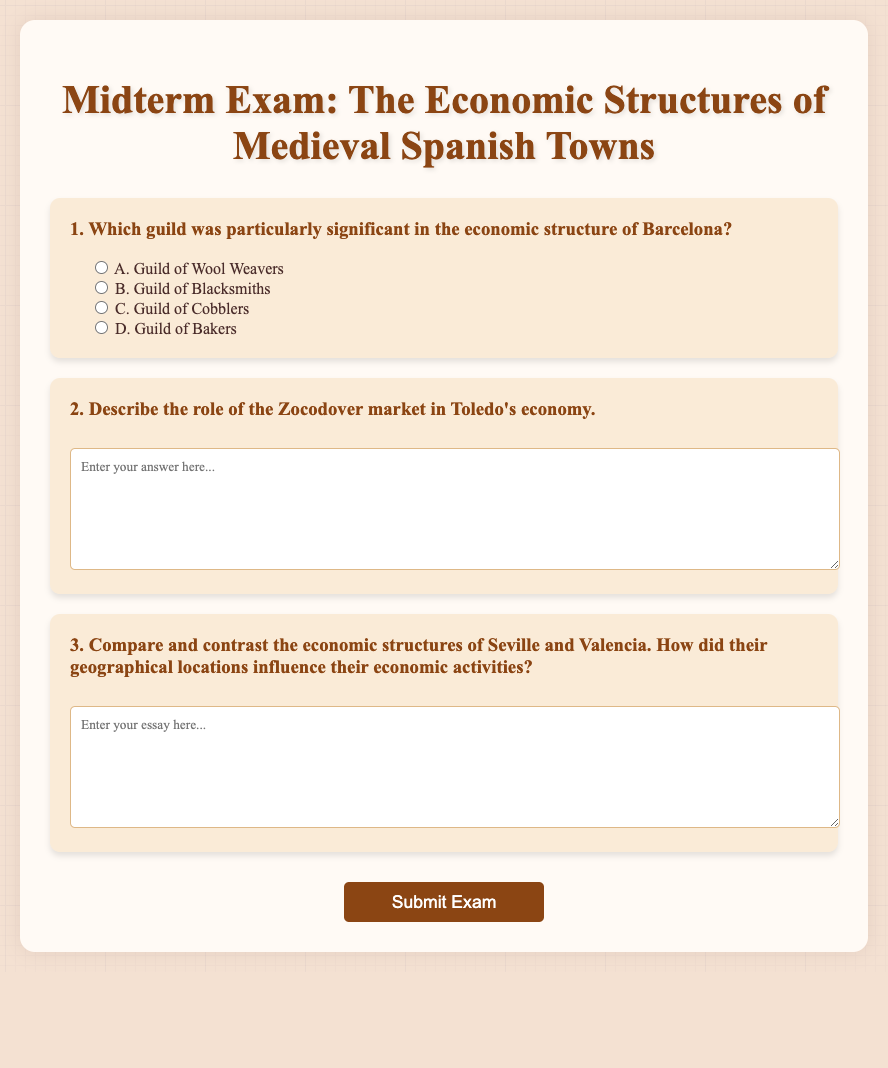What guild was particularly significant in the economic structure of Barcelona? The document lists the options for the answer but does not specify which guild is particularly significant, as it asks for a selection.
Answer: Guild of Wool Weavers What is the title of the midterm exam? The title of the exam is clearly stated at the top of the document.
Answer: Midterm Exam: The Economic Structures of Medieval Spanish Towns What role does the Zocodover market play in Toledo's economy? The exam asks the participant to describe this role in a text box, implying its significance is important.
Answer: Economic role How many questions are in the document? The document has a specific structure showcasing a total count of questions listed numerically.
Answer: 3 What type of questions are asked in this exam? The exam includes both selection and descriptive types of questions, showcasing an assessment of knowledge and understanding.
Answer: Short-answer questions Which city is mentioned in connection with a guild of bakers? The document presents a multiple-choice question about various guilds, implying connections with certain cities.
Answer: Barcelona What are students required to do with the questions in this midterm exam? The instructions imply an action that the student must perform concerning the questions provided.
Answer: Answer/submit What feature is included in the design of the document to help organize content visually? The design includes specific styles and elements that make the content more appealing and navigable, such as headers and div sections.
Answer: Container elements 